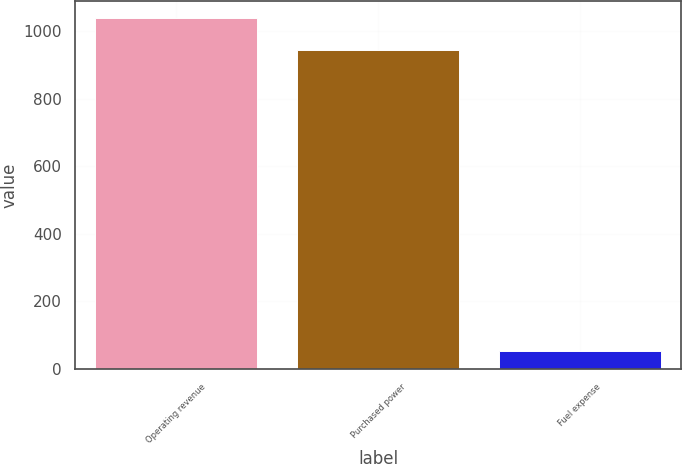Convert chart to OTSL. <chart><loc_0><loc_0><loc_500><loc_500><bar_chart><fcel>Operating revenue<fcel>Purchased power<fcel>Fuel expense<nl><fcel>1037.3<fcel>943<fcel>53<nl></chart> 